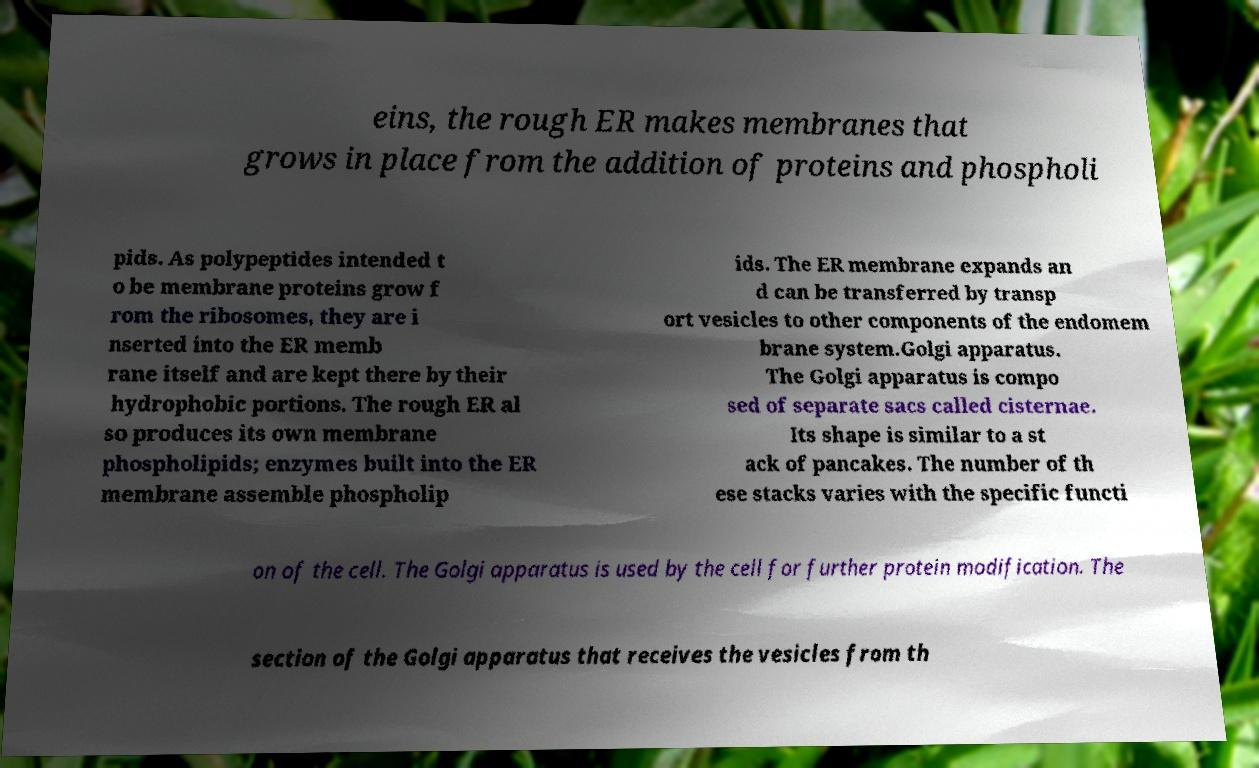There's text embedded in this image that I need extracted. Can you transcribe it verbatim? eins, the rough ER makes membranes that grows in place from the addition of proteins and phospholi pids. As polypeptides intended t o be membrane proteins grow f rom the ribosomes, they are i nserted into the ER memb rane itself and are kept there by their hydrophobic portions. The rough ER al so produces its own membrane phospholipids; enzymes built into the ER membrane assemble phospholip ids. The ER membrane expands an d can be transferred by transp ort vesicles to other components of the endomem brane system.Golgi apparatus. The Golgi apparatus is compo sed of separate sacs called cisternae. Its shape is similar to a st ack of pancakes. The number of th ese stacks varies with the specific functi on of the cell. The Golgi apparatus is used by the cell for further protein modification. The section of the Golgi apparatus that receives the vesicles from th 